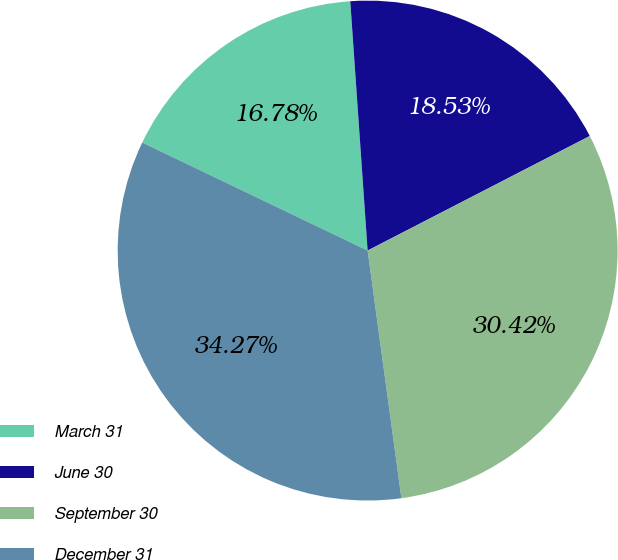<chart> <loc_0><loc_0><loc_500><loc_500><pie_chart><fcel>March 31<fcel>June 30<fcel>September 30<fcel>December 31<nl><fcel>16.78%<fcel>18.53%<fcel>30.42%<fcel>34.27%<nl></chart> 